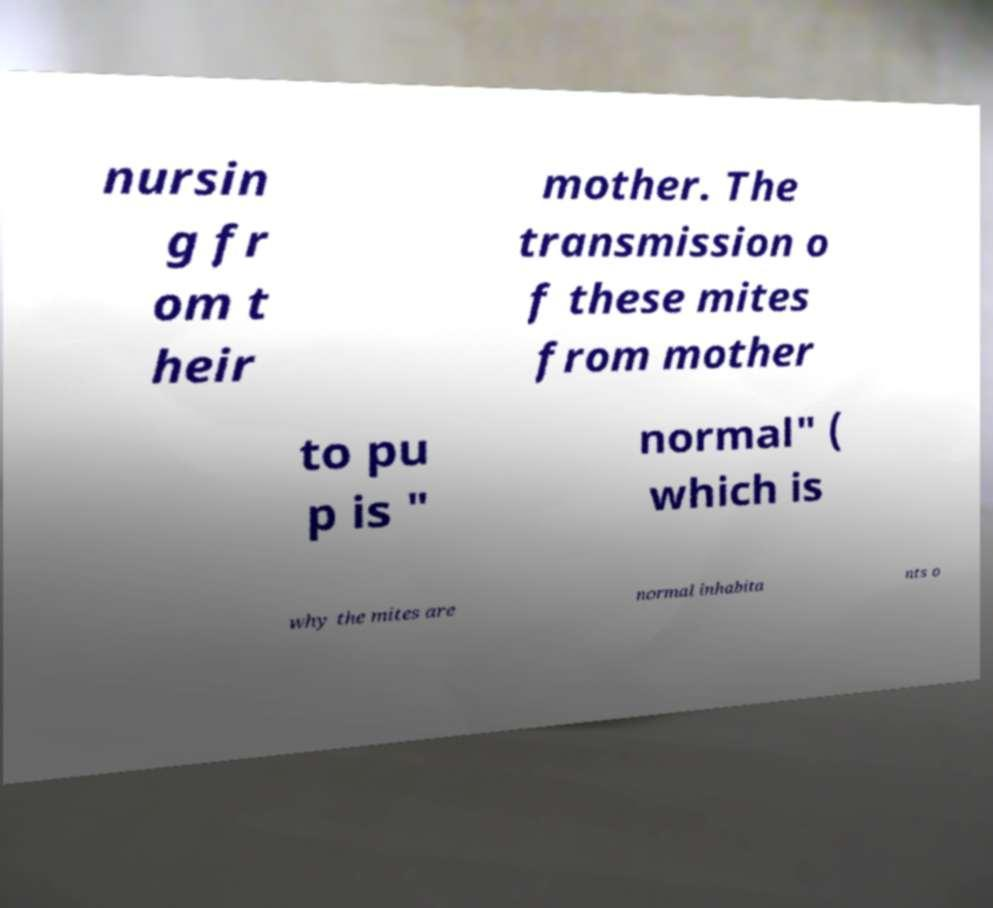Can you accurately transcribe the text from the provided image for me? nursin g fr om t heir mother. The transmission o f these mites from mother to pu p is " normal" ( which is why the mites are normal inhabita nts o 